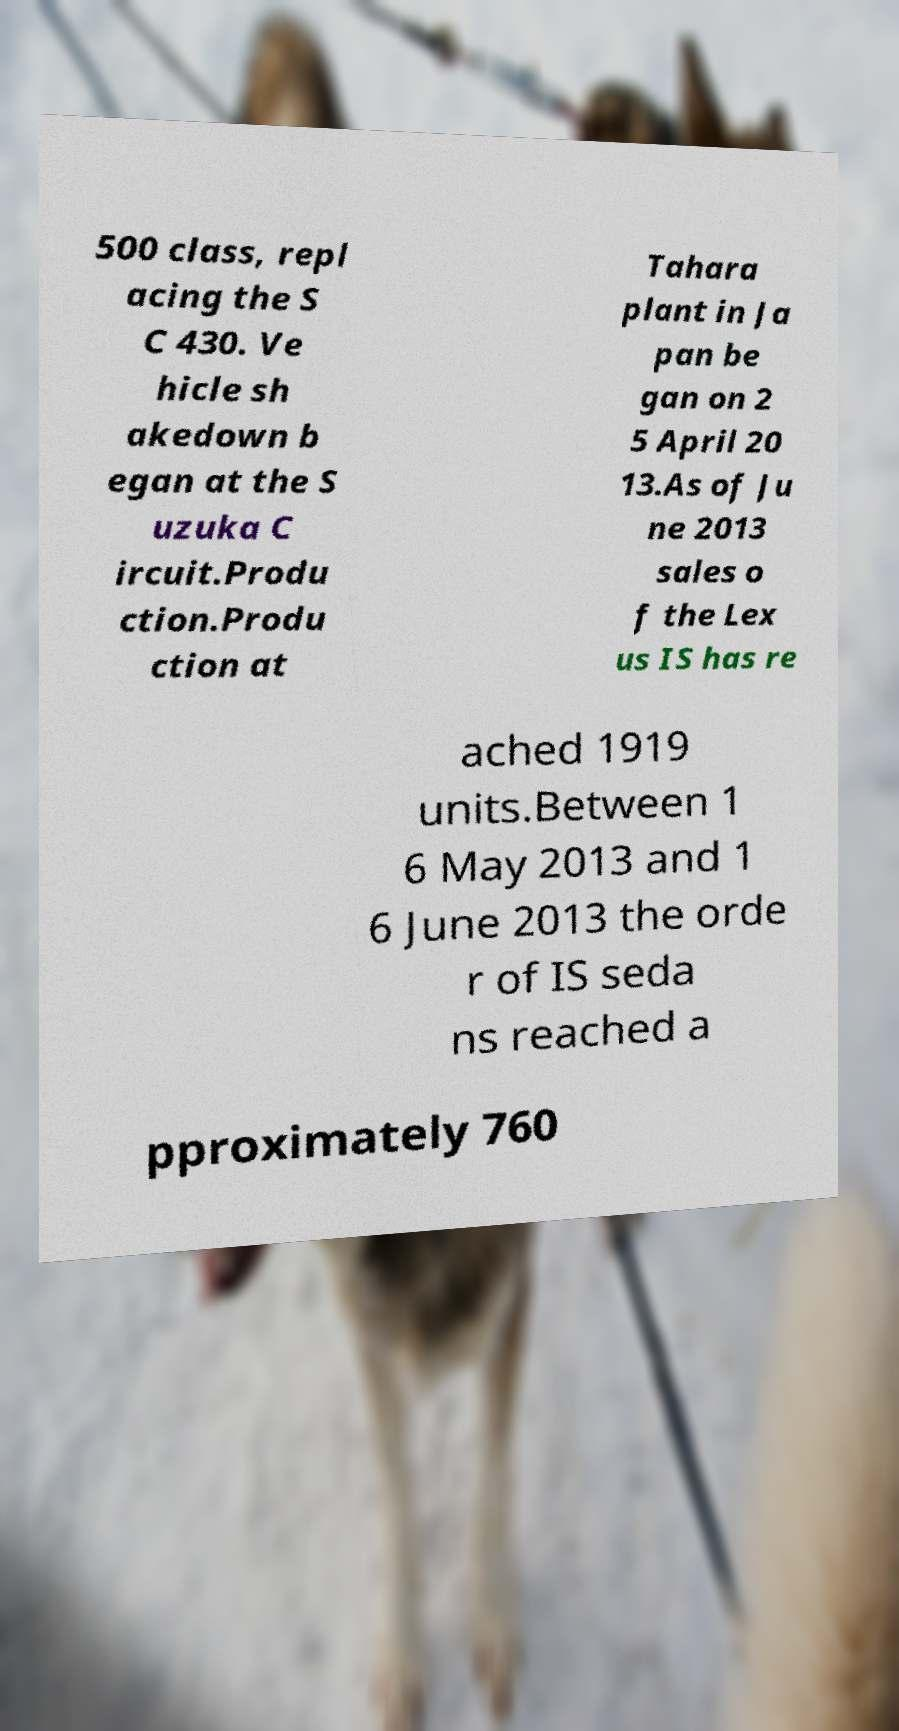Please identify and transcribe the text found in this image. 500 class, repl acing the S C 430. Ve hicle sh akedown b egan at the S uzuka C ircuit.Produ ction.Produ ction at Tahara plant in Ja pan be gan on 2 5 April 20 13.As of Ju ne 2013 sales o f the Lex us IS has re ached 1919 units.Between 1 6 May 2013 and 1 6 June 2013 the orde r of IS seda ns reached a pproximately 760 